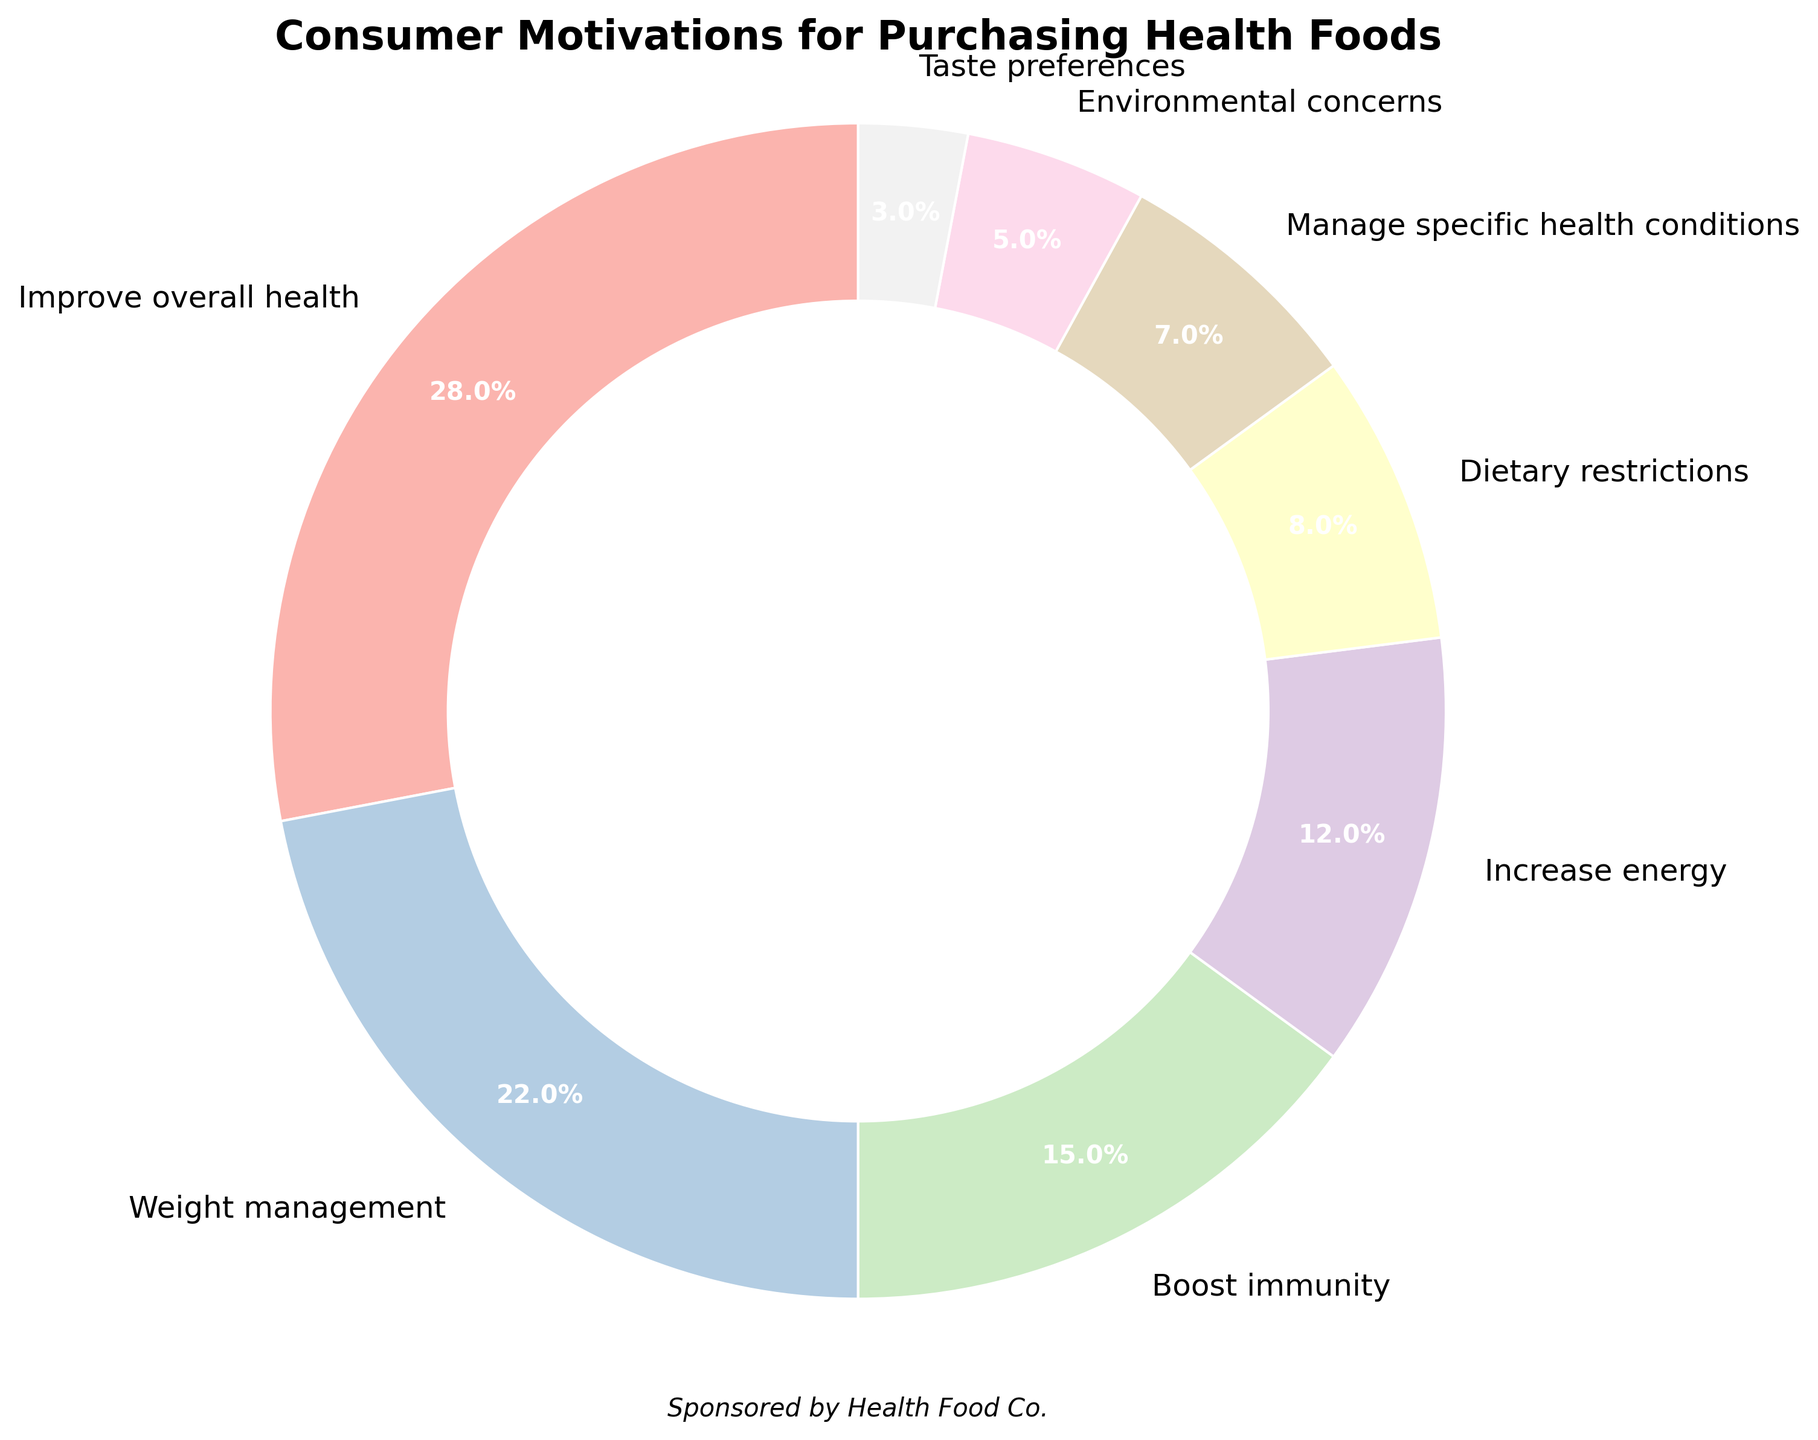What percentage of consumers purchase health foods for dietary restrictions? The figure indicates the percentage breakdown for each motivation category. Locate the segment labeled "Dietary restrictions" and refer to the percentage shown.
Answer: 8% Which motivation category has the highest percentage of consumers? Examine all the segments in the pie chart and find the one with the largest percentage.
Answer: Improve overall health How much greater is the percentage of consumers motivated by weight management compared to those motivated by taste preferences? Find the percentages for "Weight management" and "Taste preferences" and subtract the latter from the former: 22% - 3% = 19%.
Answer: 19% What is the combined percentage of consumers who purchase health foods for specific health conditions and environmental concerns? Add the percentages of the segments labeled "Manage specific health conditions" (7%) and "Environmental concerns" (5%): 7% + 5% = 12%.
Answer: 12% Which is lesser, the percentage of consumers motivated by boosting immunity or those motivated by increasing energy? Compare the percentages of the segments labeled "Boost immunity" (15%) and "Increase energy" (12%): 12% < 15%.
Answer: Increase energy What fraction of consumers are motivated by either weight management or boosting immunity? Add the percentages of the segments labeled "Weight management" (22%) and "Boost immunity" (15%) and convert to a fraction of 100: (22% + 15%)/100 = 37/100.
Answer: 37/100 How much more significant is the percentage of consumers motivated by improving overall health compared to those motivated by environmental concerns? Find the difference between the percentages for "Improve overall health" (28%) and "Environmental concerns" (5%): 28% - 5% = 23%.
Answer: 23% Does the sum percentage of "Weight management" and "Boost immunity" exceed "Improve overall health"? Add the percentages of the segments labeled "Weight management" (22%) and "Boost immunity" (15%) and compare to "Improve overall health" (28%): 22% + 15% = 37%, and 37% > 28%.
Answer: Yes 